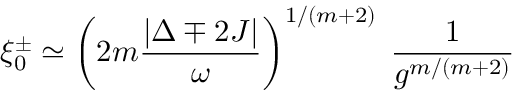<formula> <loc_0><loc_0><loc_500><loc_500>\xi _ { 0 } ^ { \pm } \simeq \left ( 2 m \frac { | \Delta \mp 2 J | } { \omega } \right ) ^ { 1 / ( m + 2 ) } \, \frac { 1 } { g ^ { m / ( m + 2 ) } }</formula> 